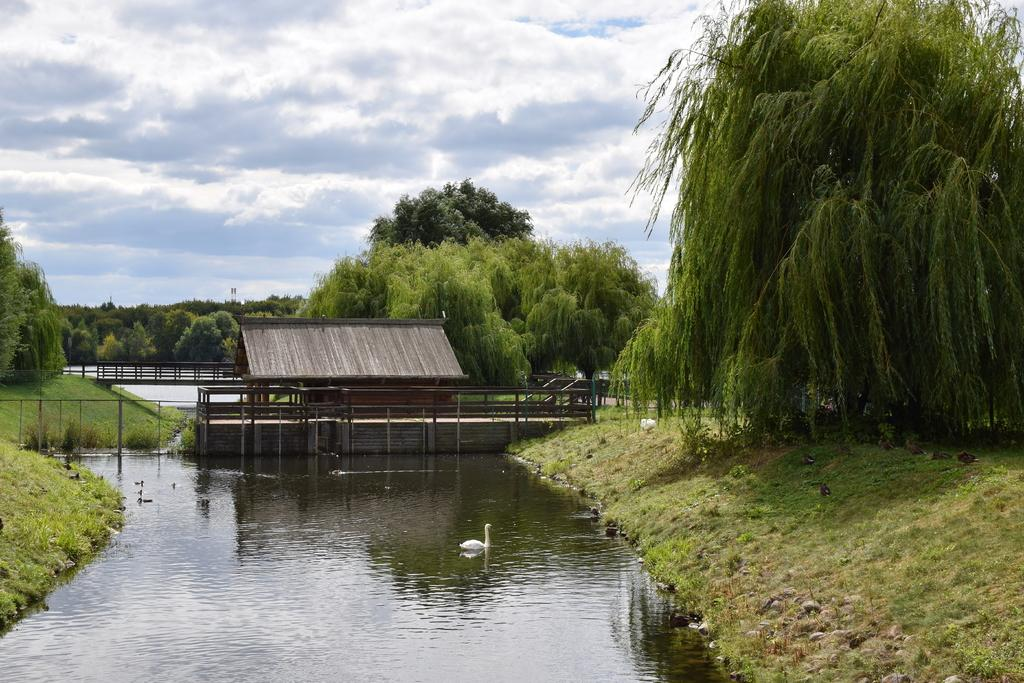What type of structure can be seen in the image? There is a bridge in the image. What other structure is present in the image? There is a shed in the image. What can be seen in the background of the image? There are trees in the background of the image. What is in the water at the bottom of the image? There is a swan in the water at the bottom of the image. What is visible in the sky at the top of the image? There are clouds in the sky at the top of the image. What type of instrument is being played by the swan in the image? There is no instrument being played by the swan in the image, as swans do not play musical instruments. 